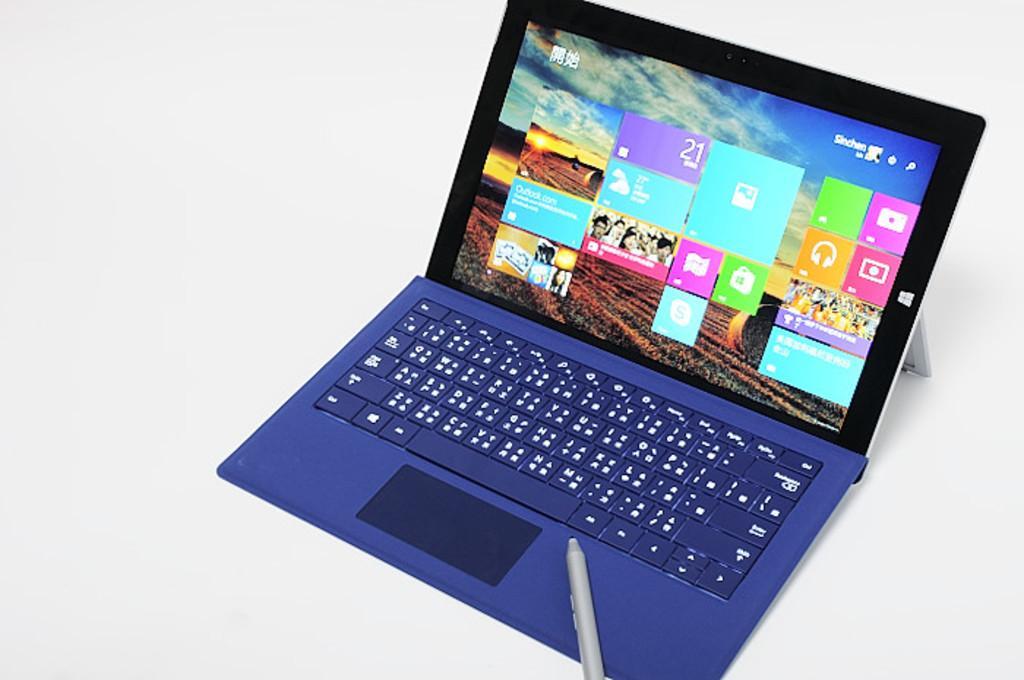Describe this image in one or two sentences. In this image we can see a laptop and a marker placed on top of it. 